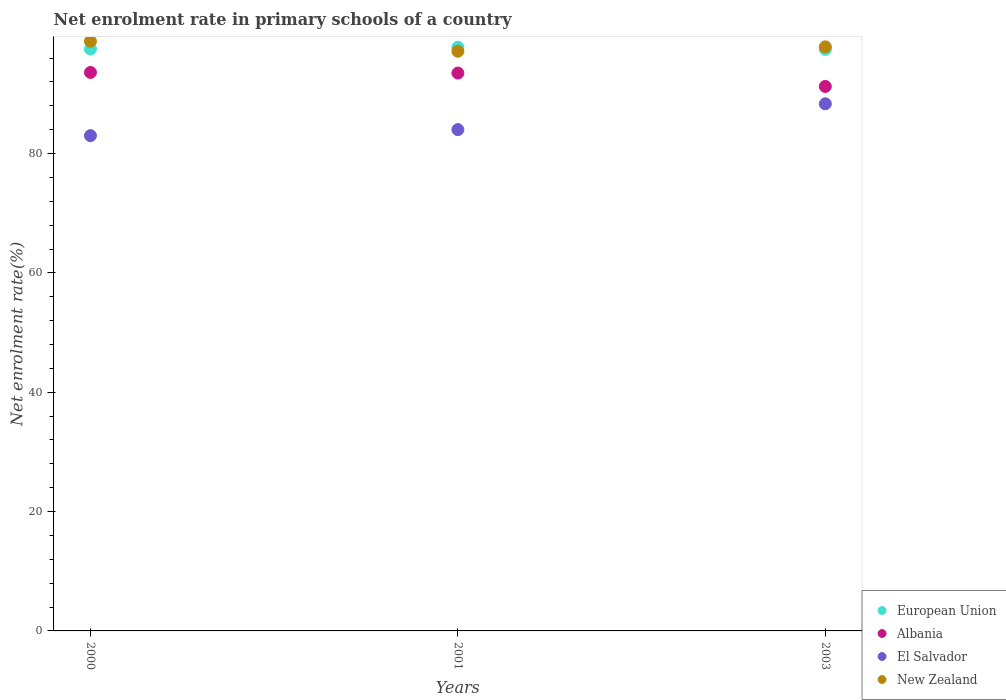Is the number of dotlines equal to the number of legend labels?
Keep it short and to the point. Yes. What is the net enrolment rate in primary schools in New Zealand in 2001?
Offer a terse response. 97.15. Across all years, what is the maximum net enrolment rate in primary schools in Albania?
Give a very brief answer. 93.6. Across all years, what is the minimum net enrolment rate in primary schools in New Zealand?
Ensure brevity in your answer.  97.15. In which year was the net enrolment rate in primary schools in El Salvador minimum?
Your answer should be compact. 2000. What is the total net enrolment rate in primary schools in New Zealand in the graph?
Ensure brevity in your answer.  293.86. What is the difference between the net enrolment rate in primary schools in New Zealand in 2000 and that in 2003?
Your answer should be compact. 0.93. What is the difference between the net enrolment rate in primary schools in El Salvador in 2003 and the net enrolment rate in primary schools in Albania in 2001?
Give a very brief answer. -5.15. What is the average net enrolment rate in primary schools in New Zealand per year?
Keep it short and to the point. 97.95. In the year 2001, what is the difference between the net enrolment rate in primary schools in El Salvador and net enrolment rate in primary schools in European Union?
Provide a short and direct response. -13.79. In how many years, is the net enrolment rate in primary schools in European Union greater than 64 %?
Offer a very short reply. 3. What is the ratio of the net enrolment rate in primary schools in Albania in 2000 to that in 2003?
Your answer should be compact. 1.03. Is the net enrolment rate in primary schools in El Salvador in 2001 less than that in 2003?
Provide a succinct answer. Yes. Is the difference between the net enrolment rate in primary schools in El Salvador in 2001 and 2003 greater than the difference between the net enrolment rate in primary schools in European Union in 2001 and 2003?
Make the answer very short. No. What is the difference between the highest and the second highest net enrolment rate in primary schools in El Salvador?
Your answer should be compact. 4.33. What is the difference between the highest and the lowest net enrolment rate in primary schools in European Union?
Offer a terse response. 0.34. Is the sum of the net enrolment rate in primary schools in Albania in 2000 and 2003 greater than the maximum net enrolment rate in primary schools in New Zealand across all years?
Make the answer very short. Yes. Is it the case that in every year, the sum of the net enrolment rate in primary schools in El Salvador and net enrolment rate in primary schools in Albania  is greater than the sum of net enrolment rate in primary schools in European Union and net enrolment rate in primary schools in New Zealand?
Provide a short and direct response. No. Is it the case that in every year, the sum of the net enrolment rate in primary schools in El Salvador and net enrolment rate in primary schools in New Zealand  is greater than the net enrolment rate in primary schools in European Union?
Keep it short and to the point. Yes. Does the net enrolment rate in primary schools in New Zealand monotonically increase over the years?
Offer a very short reply. No. Is the net enrolment rate in primary schools in New Zealand strictly less than the net enrolment rate in primary schools in Albania over the years?
Give a very brief answer. No. How many dotlines are there?
Your response must be concise. 4. How many years are there in the graph?
Offer a terse response. 3. Are the values on the major ticks of Y-axis written in scientific E-notation?
Keep it short and to the point. No. Does the graph contain any zero values?
Your response must be concise. No. How are the legend labels stacked?
Make the answer very short. Vertical. What is the title of the graph?
Your answer should be compact. Net enrolment rate in primary schools of a country. What is the label or title of the Y-axis?
Offer a very short reply. Net enrolment rate(%). What is the Net enrolment rate(%) in European Union in 2000?
Provide a succinct answer. 97.53. What is the Net enrolment rate(%) of Albania in 2000?
Give a very brief answer. 93.6. What is the Net enrolment rate(%) of El Salvador in 2000?
Your answer should be compact. 83.01. What is the Net enrolment rate(%) in New Zealand in 2000?
Offer a terse response. 98.82. What is the Net enrolment rate(%) of European Union in 2001?
Your answer should be compact. 97.81. What is the Net enrolment rate(%) of Albania in 2001?
Your answer should be compact. 93.5. What is the Net enrolment rate(%) of El Salvador in 2001?
Offer a terse response. 84.02. What is the Net enrolment rate(%) in New Zealand in 2001?
Your response must be concise. 97.15. What is the Net enrolment rate(%) in European Union in 2003?
Ensure brevity in your answer.  97.46. What is the Net enrolment rate(%) in Albania in 2003?
Make the answer very short. 91.25. What is the Net enrolment rate(%) of El Salvador in 2003?
Your response must be concise. 88.34. What is the Net enrolment rate(%) in New Zealand in 2003?
Keep it short and to the point. 97.89. Across all years, what is the maximum Net enrolment rate(%) in European Union?
Provide a succinct answer. 97.81. Across all years, what is the maximum Net enrolment rate(%) in Albania?
Provide a succinct answer. 93.6. Across all years, what is the maximum Net enrolment rate(%) in El Salvador?
Offer a terse response. 88.34. Across all years, what is the maximum Net enrolment rate(%) in New Zealand?
Provide a short and direct response. 98.82. Across all years, what is the minimum Net enrolment rate(%) of European Union?
Offer a very short reply. 97.46. Across all years, what is the minimum Net enrolment rate(%) of Albania?
Offer a very short reply. 91.25. Across all years, what is the minimum Net enrolment rate(%) of El Salvador?
Give a very brief answer. 83.01. Across all years, what is the minimum Net enrolment rate(%) of New Zealand?
Your answer should be very brief. 97.15. What is the total Net enrolment rate(%) in European Union in the graph?
Offer a terse response. 292.79. What is the total Net enrolment rate(%) in Albania in the graph?
Keep it short and to the point. 278.35. What is the total Net enrolment rate(%) of El Salvador in the graph?
Offer a terse response. 255.36. What is the total Net enrolment rate(%) of New Zealand in the graph?
Ensure brevity in your answer.  293.86. What is the difference between the Net enrolment rate(%) in European Union in 2000 and that in 2001?
Offer a terse response. -0.28. What is the difference between the Net enrolment rate(%) of Albania in 2000 and that in 2001?
Your answer should be very brief. 0.11. What is the difference between the Net enrolment rate(%) in El Salvador in 2000 and that in 2001?
Make the answer very short. -1.01. What is the difference between the Net enrolment rate(%) in New Zealand in 2000 and that in 2001?
Give a very brief answer. 1.67. What is the difference between the Net enrolment rate(%) in European Union in 2000 and that in 2003?
Your answer should be very brief. 0.06. What is the difference between the Net enrolment rate(%) in Albania in 2000 and that in 2003?
Your answer should be compact. 2.35. What is the difference between the Net enrolment rate(%) of El Salvador in 2000 and that in 2003?
Offer a terse response. -5.34. What is the difference between the Net enrolment rate(%) of New Zealand in 2000 and that in 2003?
Keep it short and to the point. 0.93. What is the difference between the Net enrolment rate(%) in European Union in 2001 and that in 2003?
Give a very brief answer. 0.34. What is the difference between the Net enrolment rate(%) in Albania in 2001 and that in 2003?
Give a very brief answer. 2.25. What is the difference between the Net enrolment rate(%) of El Salvador in 2001 and that in 2003?
Your answer should be compact. -4.33. What is the difference between the Net enrolment rate(%) of New Zealand in 2001 and that in 2003?
Provide a succinct answer. -0.74. What is the difference between the Net enrolment rate(%) of European Union in 2000 and the Net enrolment rate(%) of Albania in 2001?
Give a very brief answer. 4.03. What is the difference between the Net enrolment rate(%) of European Union in 2000 and the Net enrolment rate(%) of El Salvador in 2001?
Make the answer very short. 13.51. What is the difference between the Net enrolment rate(%) of European Union in 2000 and the Net enrolment rate(%) of New Zealand in 2001?
Offer a terse response. 0.38. What is the difference between the Net enrolment rate(%) in Albania in 2000 and the Net enrolment rate(%) in El Salvador in 2001?
Offer a terse response. 9.59. What is the difference between the Net enrolment rate(%) of Albania in 2000 and the Net enrolment rate(%) of New Zealand in 2001?
Your response must be concise. -3.55. What is the difference between the Net enrolment rate(%) of El Salvador in 2000 and the Net enrolment rate(%) of New Zealand in 2001?
Your answer should be very brief. -14.14. What is the difference between the Net enrolment rate(%) of European Union in 2000 and the Net enrolment rate(%) of Albania in 2003?
Offer a terse response. 6.28. What is the difference between the Net enrolment rate(%) in European Union in 2000 and the Net enrolment rate(%) in El Salvador in 2003?
Offer a very short reply. 9.18. What is the difference between the Net enrolment rate(%) in European Union in 2000 and the Net enrolment rate(%) in New Zealand in 2003?
Make the answer very short. -0.36. What is the difference between the Net enrolment rate(%) in Albania in 2000 and the Net enrolment rate(%) in El Salvador in 2003?
Offer a terse response. 5.26. What is the difference between the Net enrolment rate(%) of Albania in 2000 and the Net enrolment rate(%) of New Zealand in 2003?
Give a very brief answer. -4.28. What is the difference between the Net enrolment rate(%) in El Salvador in 2000 and the Net enrolment rate(%) in New Zealand in 2003?
Ensure brevity in your answer.  -14.88. What is the difference between the Net enrolment rate(%) in European Union in 2001 and the Net enrolment rate(%) in Albania in 2003?
Ensure brevity in your answer.  6.56. What is the difference between the Net enrolment rate(%) in European Union in 2001 and the Net enrolment rate(%) in El Salvador in 2003?
Provide a succinct answer. 9.46. What is the difference between the Net enrolment rate(%) of European Union in 2001 and the Net enrolment rate(%) of New Zealand in 2003?
Your answer should be compact. -0.08. What is the difference between the Net enrolment rate(%) in Albania in 2001 and the Net enrolment rate(%) in El Salvador in 2003?
Keep it short and to the point. 5.15. What is the difference between the Net enrolment rate(%) of Albania in 2001 and the Net enrolment rate(%) of New Zealand in 2003?
Provide a succinct answer. -4.39. What is the difference between the Net enrolment rate(%) of El Salvador in 2001 and the Net enrolment rate(%) of New Zealand in 2003?
Your answer should be compact. -13.87. What is the average Net enrolment rate(%) of European Union per year?
Make the answer very short. 97.6. What is the average Net enrolment rate(%) of Albania per year?
Provide a short and direct response. 92.78. What is the average Net enrolment rate(%) in El Salvador per year?
Keep it short and to the point. 85.12. What is the average Net enrolment rate(%) in New Zealand per year?
Keep it short and to the point. 97.95. In the year 2000, what is the difference between the Net enrolment rate(%) of European Union and Net enrolment rate(%) of Albania?
Keep it short and to the point. 3.92. In the year 2000, what is the difference between the Net enrolment rate(%) of European Union and Net enrolment rate(%) of El Salvador?
Ensure brevity in your answer.  14.52. In the year 2000, what is the difference between the Net enrolment rate(%) of European Union and Net enrolment rate(%) of New Zealand?
Keep it short and to the point. -1.29. In the year 2000, what is the difference between the Net enrolment rate(%) of Albania and Net enrolment rate(%) of El Salvador?
Your answer should be compact. 10.6. In the year 2000, what is the difference between the Net enrolment rate(%) of Albania and Net enrolment rate(%) of New Zealand?
Give a very brief answer. -5.22. In the year 2000, what is the difference between the Net enrolment rate(%) in El Salvador and Net enrolment rate(%) in New Zealand?
Make the answer very short. -15.81. In the year 2001, what is the difference between the Net enrolment rate(%) in European Union and Net enrolment rate(%) in Albania?
Provide a short and direct response. 4.31. In the year 2001, what is the difference between the Net enrolment rate(%) in European Union and Net enrolment rate(%) in El Salvador?
Provide a succinct answer. 13.79. In the year 2001, what is the difference between the Net enrolment rate(%) in European Union and Net enrolment rate(%) in New Zealand?
Give a very brief answer. 0.66. In the year 2001, what is the difference between the Net enrolment rate(%) in Albania and Net enrolment rate(%) in El Salvador?
Ensure brevity in your answer.  9.48. In the year 2001, what is the difference between the Net enrolment rate(%) of Albania and Net enrolment rate(%) of New Zealand?
Provide a succinct answer. -3.65. In the year 2001, what is the difference between the Net enrolment rate(%) of El Salvador and Net enrolment rate(%) of New Zealand?
Your response must be concise. -13.13. In the year 2003, what is the difference between the Net enrolment rate(%) in European Union and Net enrolment rate(%) in Albania?
Your answer should be compact. 6.21. In the year 2003, what is the difference between the Net enrolment rate(%) in European Union and Net enrolment rate(%) in El Salvador?
Your response must be concise. 9.12. In the year 2003, what is the difference between the Net enrolment rate(%) in European Union and Net enrolment rate(%) in New Zealand?
Your response must be concise. -0.42. In the year 2003, what is the difference between the Net enrolment rate(%) of Albania and Net enrolment rate(%) of El Salvador?
Make the answer very short. 2.91. In the year 2003, what is the difference between the Net enrolment rate(%) in Albania and Net enrolment rate(%) in New Zealand?
Your answer should be very brief. -6.64. In the year 2003, what is the difference between the Net enrolment rate(%) in El Salvador and Net enrolment rate(%) in New Zealand?
Offer a very short reply. -9.54. What is the ratio of the Net enrolment rate(%) in European Union in 2000 to that in 2001?
Your answer should be compact. 1. What is the ratio of the Net enrolment rate(%) of Albania in 2000 to that in 2001?
Ensure brevity in your answer.  1. What is the ratio of the Net enrolment rate(%) of New Zealand in 2000 to that in 2001?
Ensure brevity in your answer.  1.02. What is the ratio of the Net enrolment rate(%) of European Union in 2000 to that in 2003?
Offer a very short reply. 1. What is the ratio of the Net enrolment rate(%) in Albania in 2000 to that in 2003?
Provide a short and direct response. 1.03. What is the ratio of the Net enrolment rate(%) of El Salvador in 2000 to that in 2003?
Make the answer very short. 0.94. What is the ratio of the Net enrolment rate(%) in New Zealand in 2000 to that in 2003?
Give a very brief answer. 1.01. What is the ratio of the Net enrolment rate(%) in European Union in 2001 to that in 2003?
Make the answer very short. 1. What is the ratio of the Net enrolment rate(%) in Albania in 2001 to that in 2003?
Your answer should be very brief. 1.02. What is the ratio of the Net enrolment rate(%) of El Salvador in 2001 to that in 2003?
Give a very brief answer. 0.95. What is the difference between the highest and the second highest Net enrolment rate(%) in European Union?
Your answer should be very brief. 0.28. What is the difference between the highest and the second highest Net enrolment rate(%) in Albania?
Your answer should be very brief. 0.11. What is the difference between the highest and the second highest Net enrolment rate(%) in El Salvador?
Offer a very short reply. 4.33. What is the difference between the highest and the second highest Net enrolment rate(%) in New Zealand?
Your answer should be very brief. 0.93. What is the difference between the highest and the lowest Net enrolment rate(%) in European Union?
Provide a succinct answer. 0.34. What is the difference between the highest and the lowest Net enrolment rate(%) in Albania?
Your response must be concise. 2.35. What is the difference between the highest and the lowest Net enrolment rate(%) of El Salvador?
Your response must be concise. 5.34. What is the difference between the highest and the lowest Net enrolment rate(%) of New Zealand?
Your answer should be very brief. 1.67. 